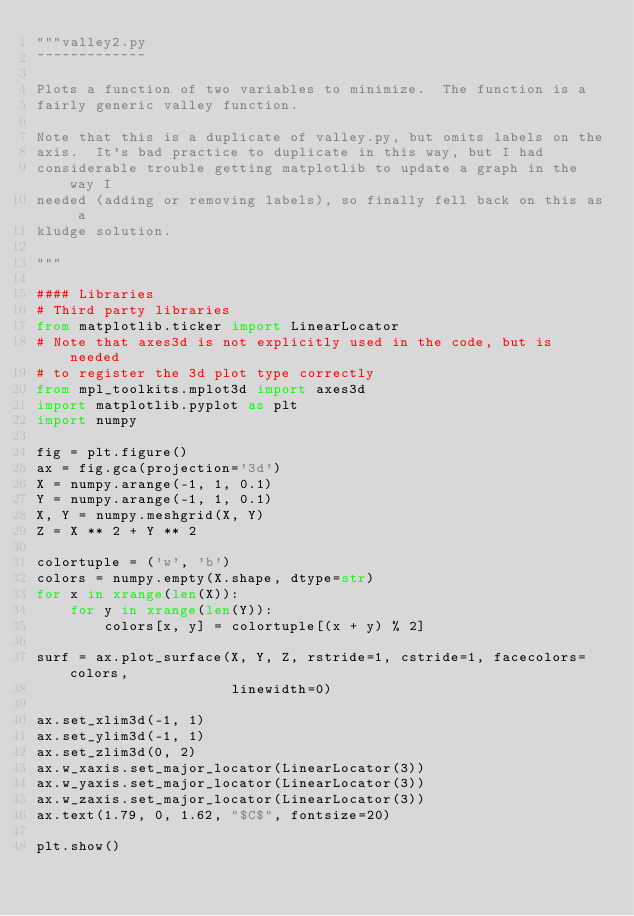Convert code to text. <code><loc_0><loc_0><loc_500><loc_500><_Python_>"""valley2.py
~~~~~~~~~~~~~

Plots a function of two variables to minimize.  The function is a
fairly generic valley function.

Note that this is a duplicate of valley.py, but omits labels on the
axis.  It's bad practice to duplicate in this way, but I had
considerable trouble getting matplotlib to update a graph in the way I
needed (adding or removing labels), so finally fell back on this as a
kludge solution.

"""

#### Libraries
# Third party libraries
from matplotlib.ticker import LinearLocator
# Note that axes3d is not explicitly used in the code, but is needed
# to register the 3d plot type correctly
from mpl_toolkits.mplot3d import axes3d
import matplotlib.pyplot as plt
import numpy

fig = plt.figure()
ax = fig.gca(projection='3d')
X = numpy.arange(-1, 1, 0.1)
Y = numpy.arange(-1, 1, 0.1)
X, Y = numpy.meshgrid(X, Y)
Z = X ** 2 + Y ** 2

colortuple = ('w', 'b')
colors = numpy.empty(X.shape, dtype=str)
for x in xrange(len(X)):
    for y in xrange(len(Y)):
        colors[x, y] = colortuple[(x + y) % 2]

surf = ax.plot_surface(X, Y, Z, rstride=1, cstride=1, facecolors=colors,
                       linewidth=0)

ax.set_xlim3d(-1, 1)
ax.set_ylim3d(-1, 1)
ax.set_zlim3d(0, 2)
ax.w_xaxis.set_major_locator(LinearLocator(3))
ax.w_yaxis.set_major_locator(LinearLocator(3))
ax.w_zaxis.set_major_locator(LinearLocator(3))
ax.text(1.79, 0, 1.62, "$C$", fontsize=20)

plt.show()
</code> 